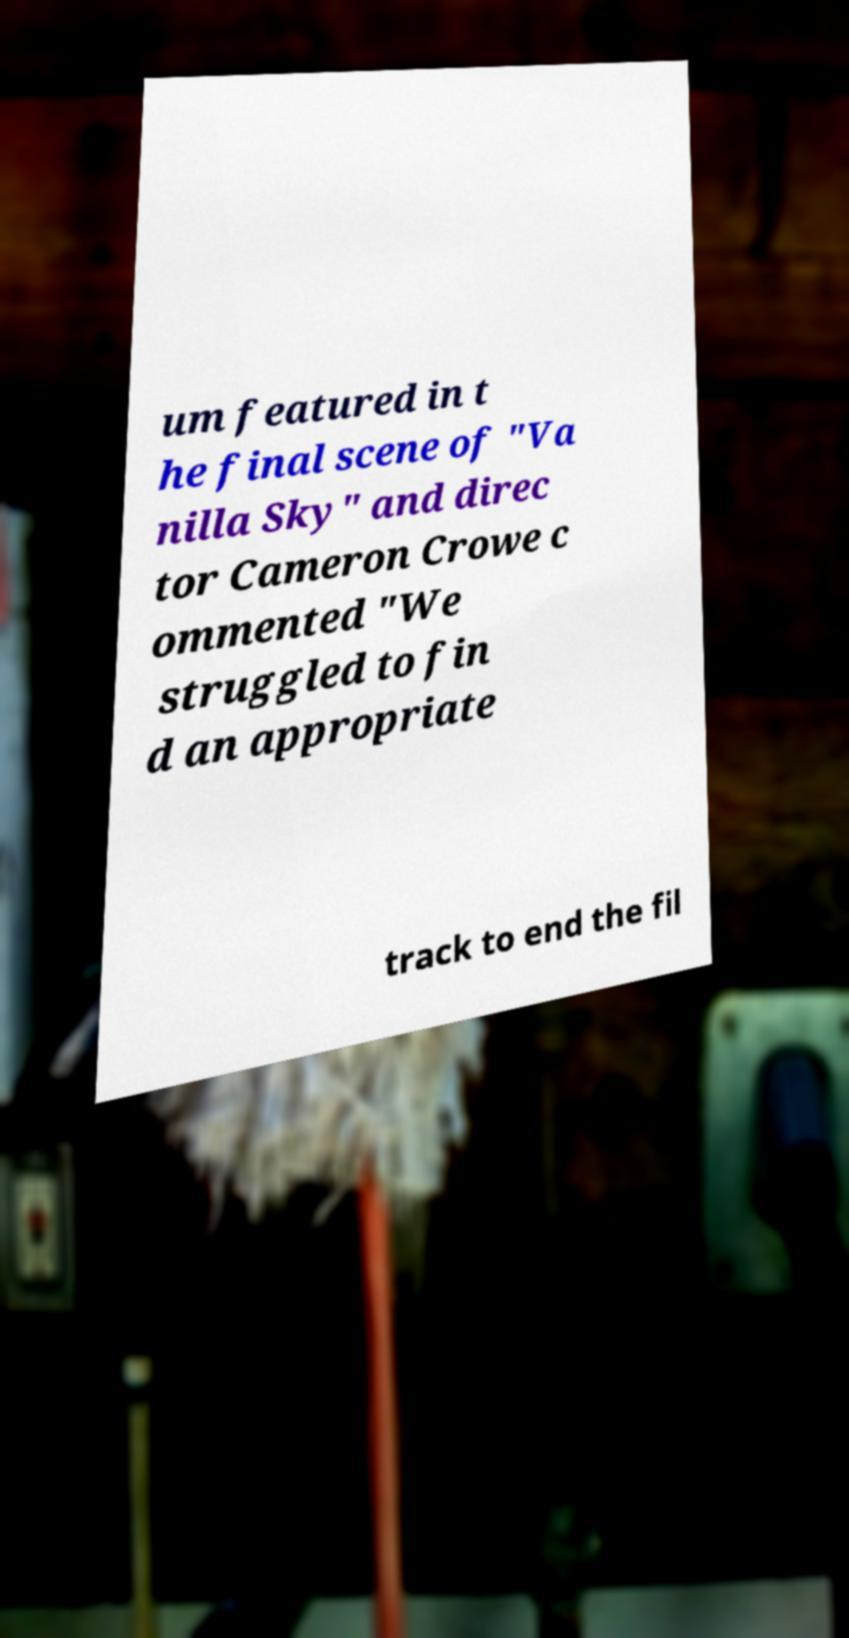What messages or text are displayed in this image? I need them in a readable, typed format. um featured in t he final scene of "Va nilla Sky" and direc tor Cameron Crowe c ommented "We struggled to fin d an appropriate track to end the fil 